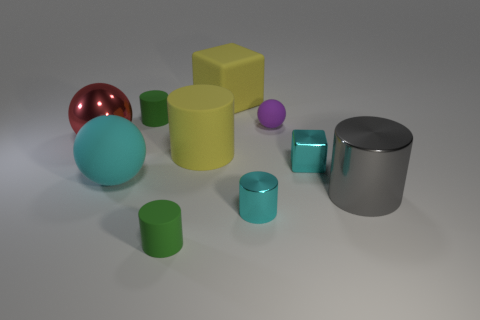The rubber cube has what size?
Offer a terse response. Large. Is there anything else that is the same material as the red ball?
Offer a very short reply. Yes. There is a small green rubber cylinder behind the small cyan object that is behind the gray metal cylinder; is there a yellow cube on the left side of it?
Your answer should be compact. No. How many small things are either metal balls or brown objects?
Your response must be concise. 0. Is there anything else that is the same color as the big metal cylinder?
Provide a succinct answer. No. There is a purple matte sphere behind the gray metallic thing; is it the same size as the small cyan cylinder?
Your response must be concise. Yes. There is a large block that is behind the block that is in front of the green object behind the tiny cyan block; what color is it?
Your answer should be very brief. Yellow. The metallic sphere is what color?
Offer a terse response. Red. Do the large cube and the large rubber cylinder have the same color?
Your response must be concise. Yes. Do the sphere in front of the big yellow rubber cylinder and the cylinder to the right of the tiny matte sphere have the same material?
Offer a terse response. No. 